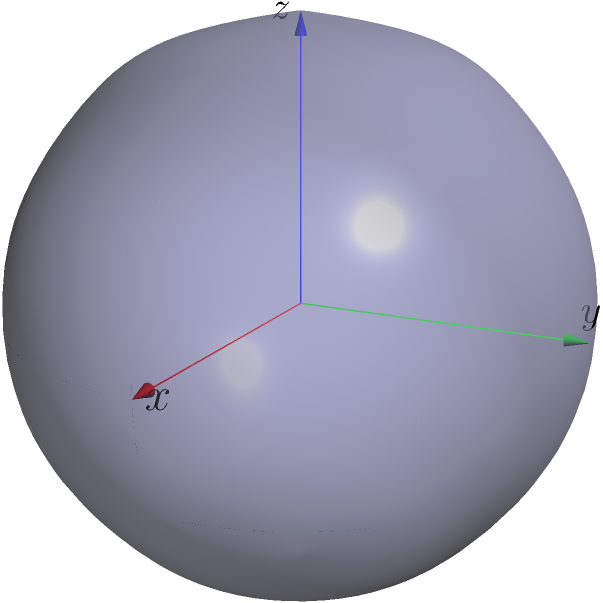Consider the matrix $A = \begin{pmatrix} 4 & 0 & 0 \\ 0 & 1 & 0 \\ 0 & 0 & 0.25 \end{pmatrix}$. This matrix represents a linear transformation that maps the unit sphere to an ellipsoid. Given the visualization of this ellipsoid, determine the eigenvalues and eigenvectors of matrix $A$, and explain their geometric interpretation in relation to the ellipsoid's shape and orientation. Let's approach this step-by-step:

1) First, we need to find the eigenvalues of matrix $A$. Since $A$ is a diagonal matrix, its eigenvalues are the elements on the main diagonal:

   $\lambda_1 = 4$, $\lambda_2 = 1$, $\lambda_3 = 0.25$

2) The eigenvectors corresponding to these eigenvalues are the standard basis vectors:

   $v_1 = (1,0,0)$, $v_2 = (0,1,0)$, $v_3 = (0,0,1)$

3) Geometric interpretation:
   a) The eigenvalues represent the scaling factors along each principal axis of the ellipsoid.
   b) The eigenvectors represent the directions of these principal axes.

4) In the given visualization:
   - The red arrow (x-axis) is the longest, corresponding to the largest eigenvalue $\lambda_1 = 4$.
   - The green arrow (y-axis) is the middle length, corresponding to $\lambda_2 = 1$.
   - The blue arrow (z-axis) is the shortest, corresponding to the smallest eigenvalue $\lambda_3 = 0.25$.

5) The lengths of the semi-axes of the ellipsoid are the square roots of the eigenvalues:
   
   $a = \sqrt{4} = 2$, $b = \sqrt{1} = 1$, $c = \sqrt{0.25} = 0.5$

6) This matches the equation of the ellipsoid: $\frac{x^2}{4} + y^2 + \frac{z^2}{0.25} = 1$

Therefore, the eigenvalues determine the shape of the ellipsoid, while the eigenvectors determine its orientation in space. In this case, the ellipsoid is aligned with the coordinate axes due to the diagonal nature of the matrix.
Answer: Eigenvalues: $\lambda_1 = 4$, $\lambda_2 = 1$, $\lambda_3 = 0.25$. Eigenvectors: $v_1 = (1,0,0)$, $v_2 = (0,1,0)$, $v_3 = (0,0,1)$. Geometrically, eigenvalues represent scaling factors along principal axes, eigenvectors indicate directions of these axes. 